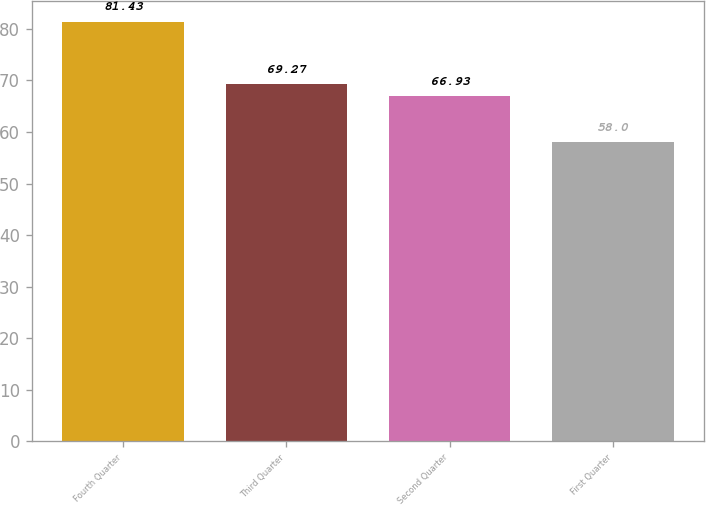Convert chart to OTSL. <chart><loc_0><loc_0><loc_500><loc_500><bar_chart><fcel>Fourth Quarter<fcel>Third Quarter<fcel>Second Quarter<fcel>First Quarter<nl><fcel>81.43<fcel>69.27<fcel>66.93<fcel>58<nl></chart> 